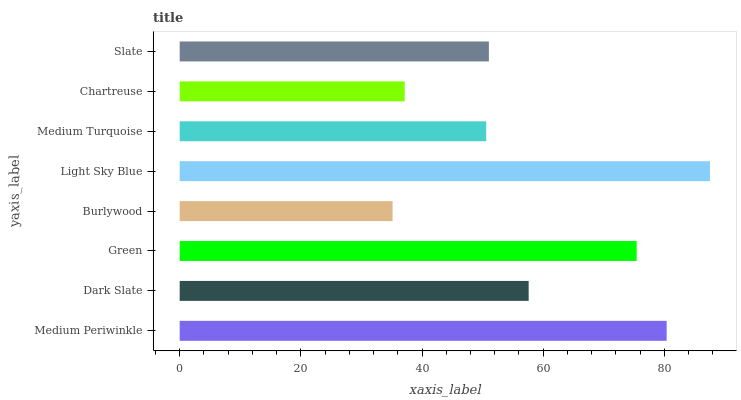Is Burlywood the minimum?
Answer yes or no. Yes. Is Light Sky Blue the maximum?
Answer yes or no. Yes. Is Dark Slate the minimum?
Answer yes or no. No. Is Dark Slate the maximum?
Answer yes or no. No. Is Medium Periwinkle greater than Dark Slate?
Answer yes or no. Yes. Is Dark Slate less than Medium Periwinkle?
Answer yes or no. Yes. Is Dark Slate greater than Medium Periwinkle?
Answer yes or no. No. Is Medium Periwinkle less than Dark Slate?
Answer yes or no. No. Is Dark Slate the high median?
Answer yes or no. Yes. Is Slate the low median?
Answer yes or no. Yes. Is Medium Periwinkle the high median?
Answer yes or no. No. Is Burlywood the low median?
Answer yes or no. No. 